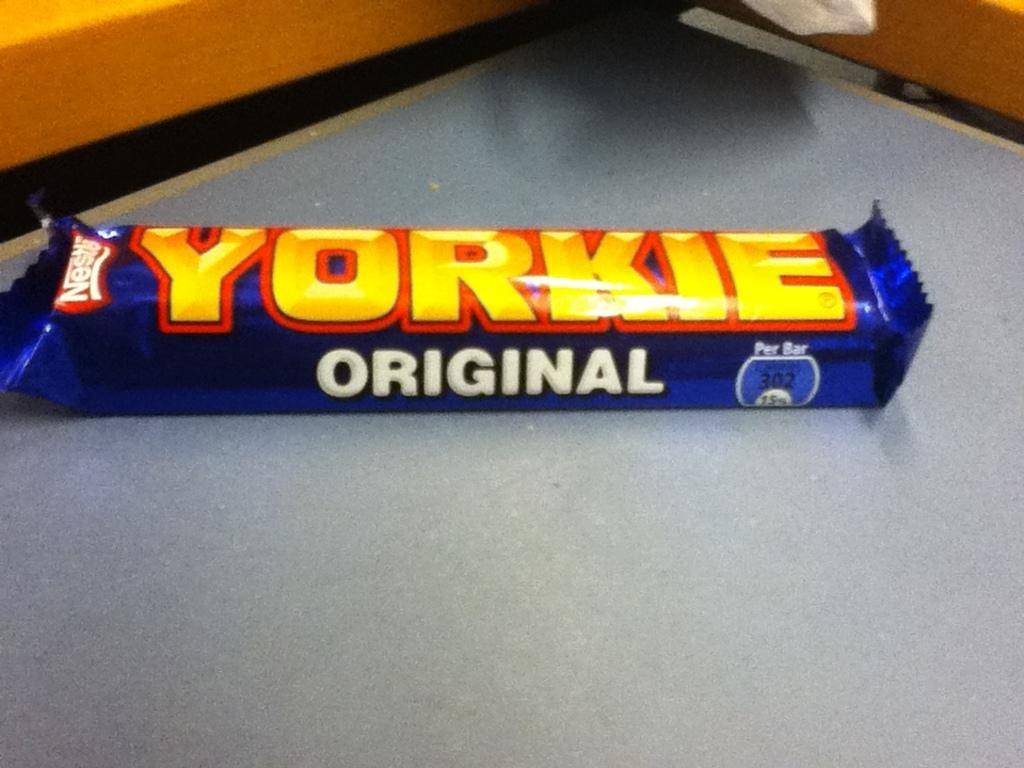What is the main subject of the image? The main subject of the image is a chocolate. Where is the chocolate located? The chocolate is on a table. How many ladybugs are resting on the wood in the image? There is no wood or ladybugs present in the image; it features a chocolate on a table. 